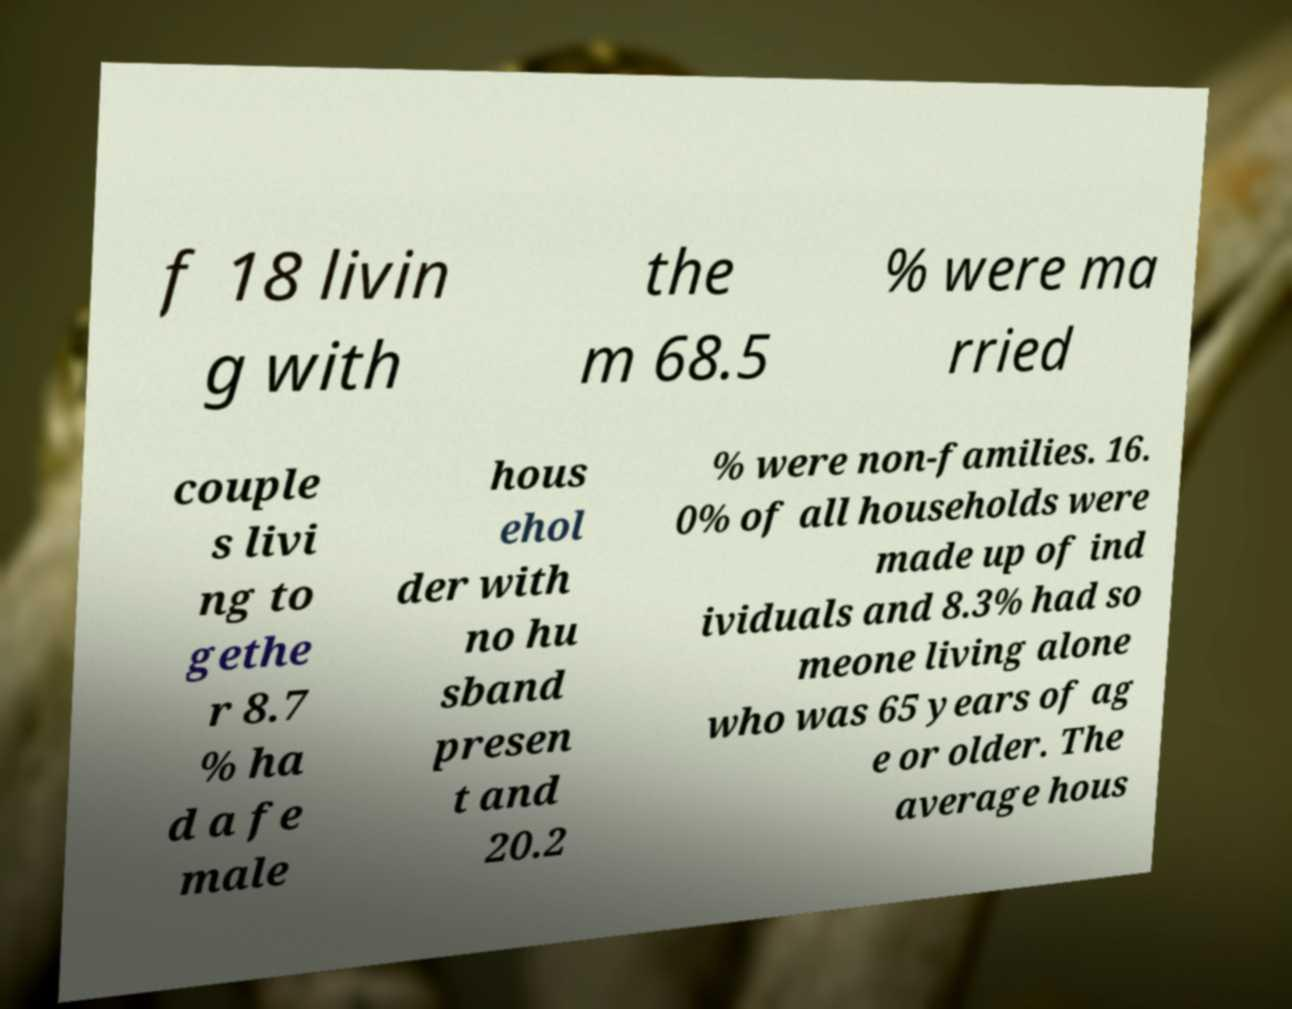Please read and relay the text visible in this image. What does it say? f 18 livin g with the m 68.5 % were ma rried couple s livi ng to gethe r 8.7 % ha d a fe male hous ehol der with no hu sband presen t and 20.2 % were non-families. 16. 0% of all households were made up of ind ividuals and 8.3% had so meone living alone who was 65 years of ag e or older. The average hous 